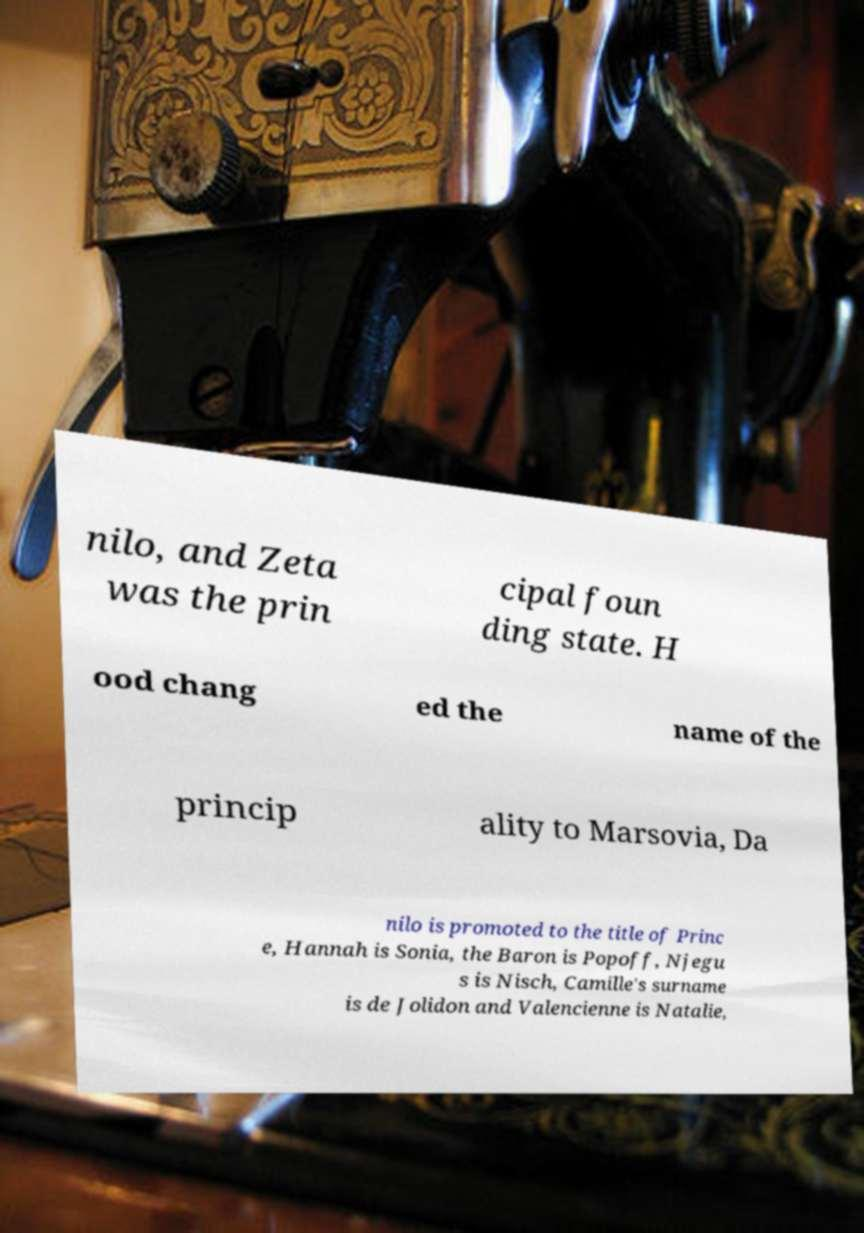I need the written content from this picture converted into text. Can you do that? nilo, and Zeta was the prin cipal foun ding state. H ood chang ed the name of the princip ality to Marsovia, Da nilo is promoted to the title of Princ e, Hannah is Sonia, the Baron is Popoff, Njegu s is Nisch, Camille's surname is de Jolidon and Valencienne is Natalie, 